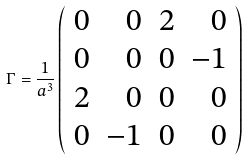<formula> <loc_0><loc_0><loc_500><loc_500>\Gamma = \frac { 1 } { a ^ { 3 } } \left ( \begin{array} { r r r r } 0 & 0 & 2 & 0 \\ 0 & 0 & 0 & - 1 \\ 2 & 0 & 0 & 0 \\ 0 & - 1 & 0 & 0 \end{array} \right )</formula> 